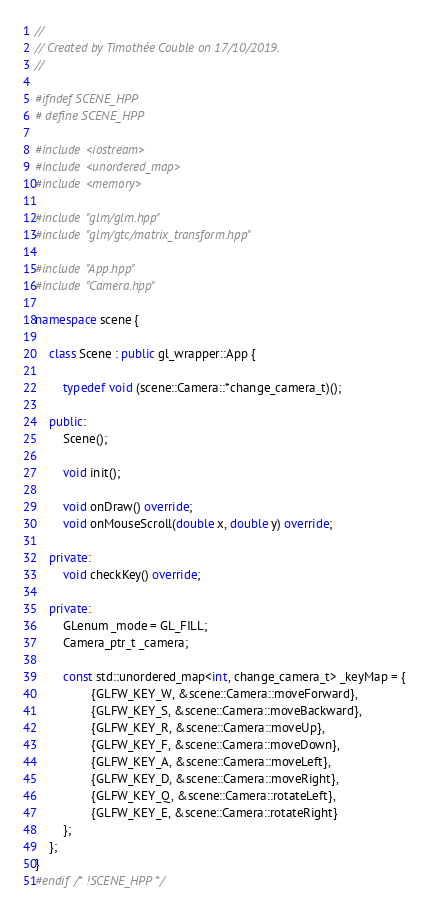Convert code to text. <code><loc_0><loc_0><loc_500><loc_500><_C++_>//
// Created by Timothée Couble on 17/10/2019.
//

#ifndef SCENE_HPP
# define SCENE_HPP

#include <iostream>
#include <unordered_map>
#include <memory>

#include "glm/glm.hpp"
#include "glm/gtc/matrix_transform.hpp"

#include "App.hpp"
#include "Camera.hpp"

namespace scene {

    class Scene : public gl_wrapper::App {

        typedef void (scene::Camera::*change_camera_t)();

    public:
        Scene();

        void init();

        void onDraw() override;
        void onMouseScroll(double x, double y) override;

    private:
        void checkKey() override;

    private:
        GLenum _mode = GL_FILL;
        Camera_ptr_t _camera;

        const std::unordered_map<int, change_camera_t> _keyMap = {
                {GLFW_KEY_W, &scene::Camera::moveForward},
                {GLFW_KEY_S, &scene::Camera::moveBackward},
                {GLFW_KEY_R, &scene::Camera::moveUp},
                {GLFW_KEY_F, &scene::Camera::moveDown},
                {GLFW_KEY_A, &scene::Camera::moveLeft},
                {GLFW_KEY_D, &scene::Camera::moveRight},
                {GLFW_KEY_Q, &scene::Camera::rotateLeft},
                {GLFW_KEY_E, &scene::Camera::rotateRight}
        };
    };
}
#endif /* !SCENE_HPP */
</code> 